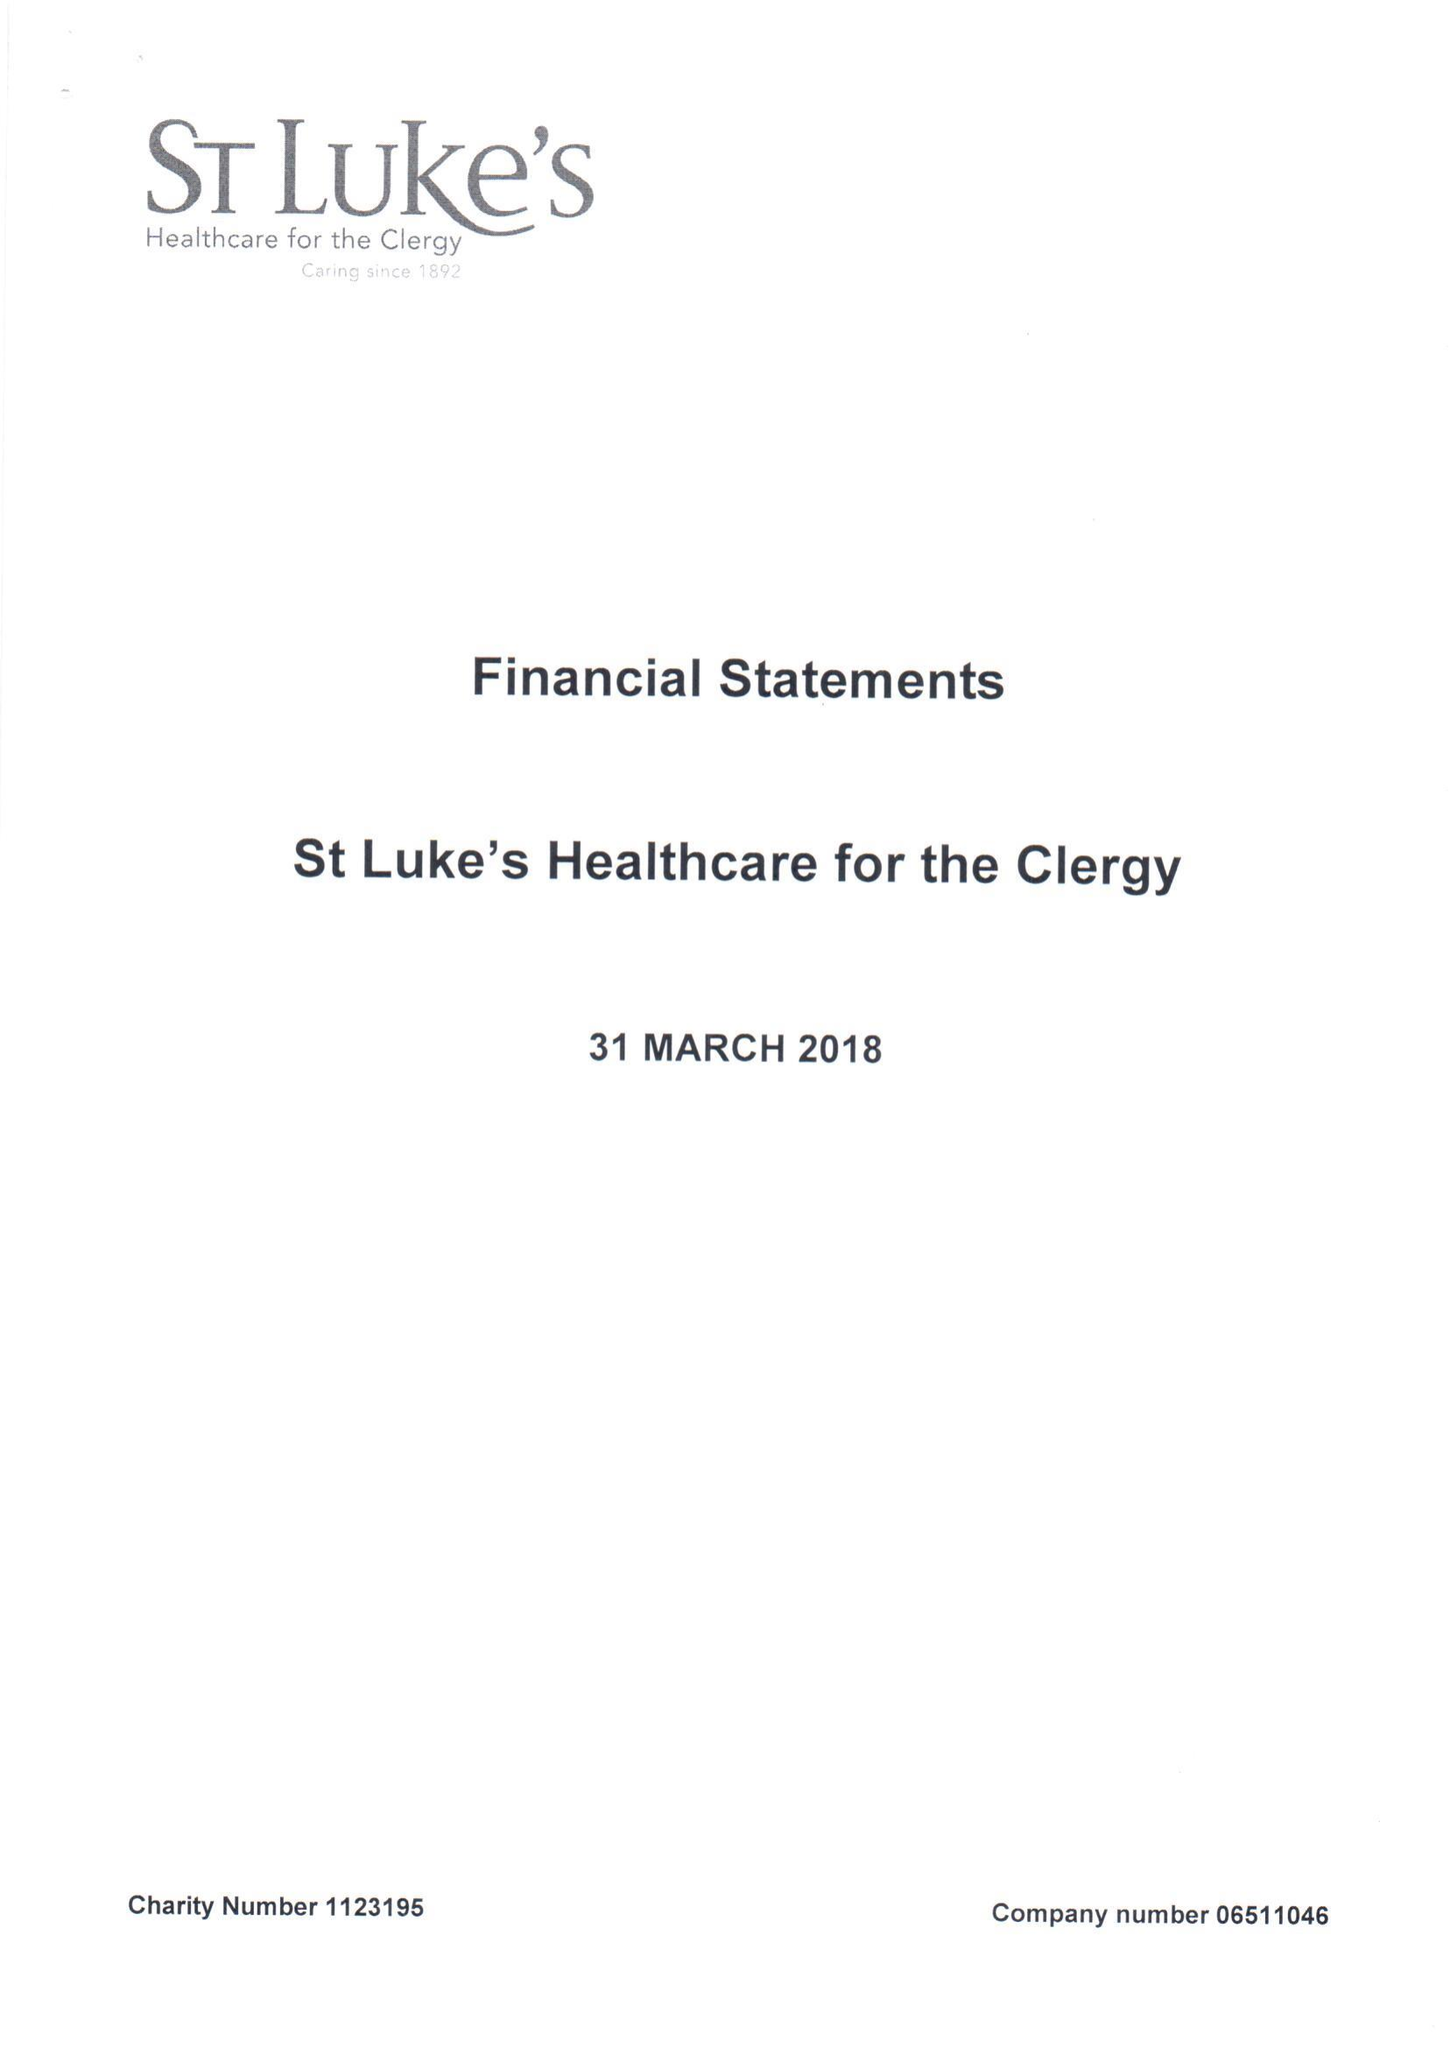What is the value for the address__post_town?
Answer the question using a single word or phrase. LONDON 